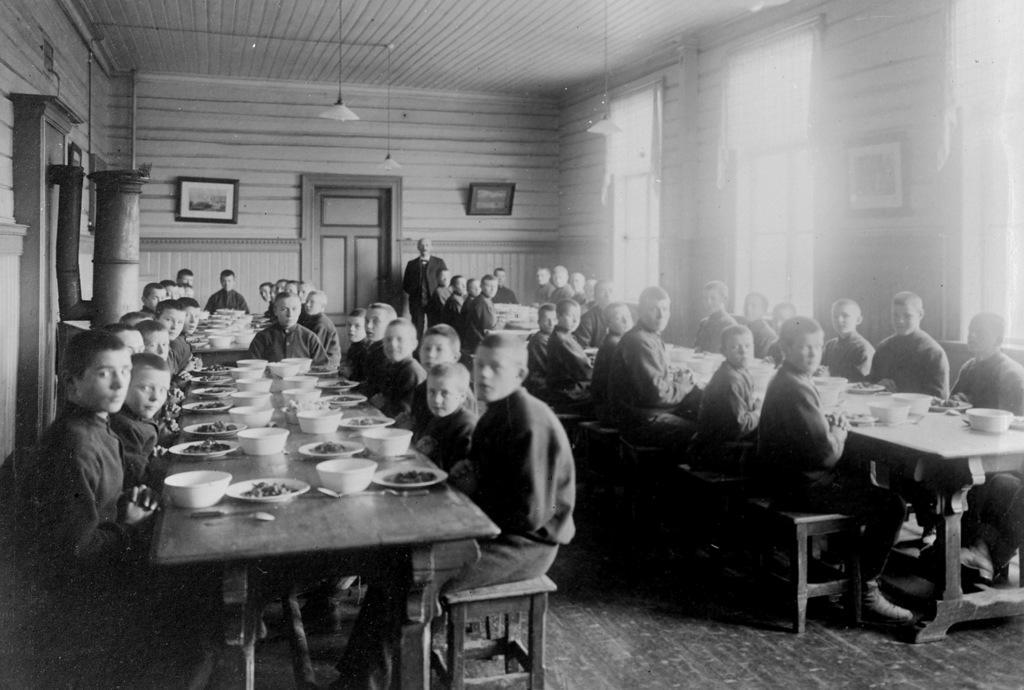How would you summarize this image in a sentence or two? This picture is taken in a room. The room is filled with the tables, chairs and people. The group of people are sitting around the table. On the every table there are some bowls, plates, and some food. I n the background there are 2 frames, a door, a lamp and a person. 